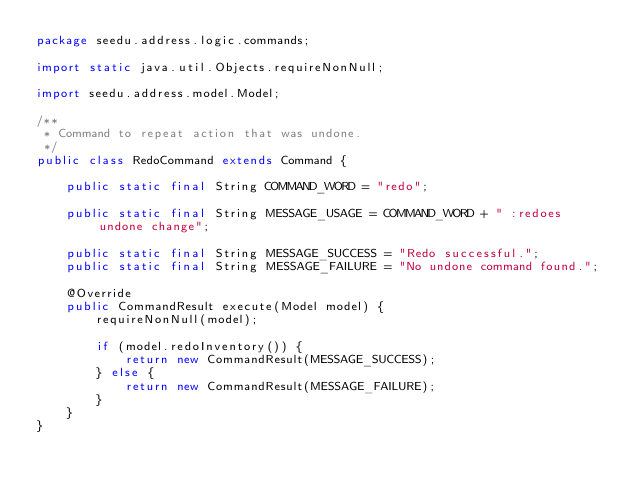<code> <loc_0><loc_0><loc_500><loc_500><_Java_>package seedu.address.logic.commands;

import static java.util.Objects.requireNonNull;

import seedu.address.model.Model;

/**
 * Command to repeat action that was undone.
 */
public class RedoCommand extends Command {

    public static final String COMMAND_WORD = "redo";

    public static final String MESSAGE_USAGE = COMMAND_WORD + " :redoes undone change";

    public static final String MESSAGE_SUCCESS = "Redo successful.";
    public static final String MESSAGE_FAILURE = "No undone command found.";

    @Override
    public CommandResult execute(Model model) {
        requireNonNull(model);

        if (model.redoInventory()) {
            return new CommandResult(MESSAGE_SUCCESS);
        } else {
            return new CommandResult(MESSAGE_FAILURE);
        }
    }
}
</code> 